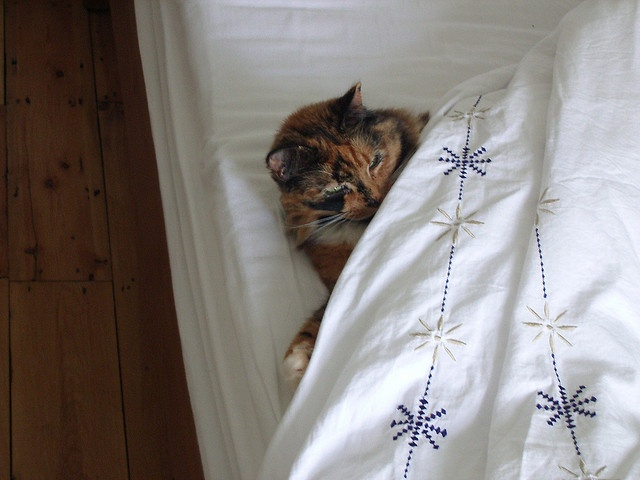Describe the objects in this image and their specific colors. I can see bed in black, darkgray, and gray tones and cat in black, maroon, and gray tones in this image. 